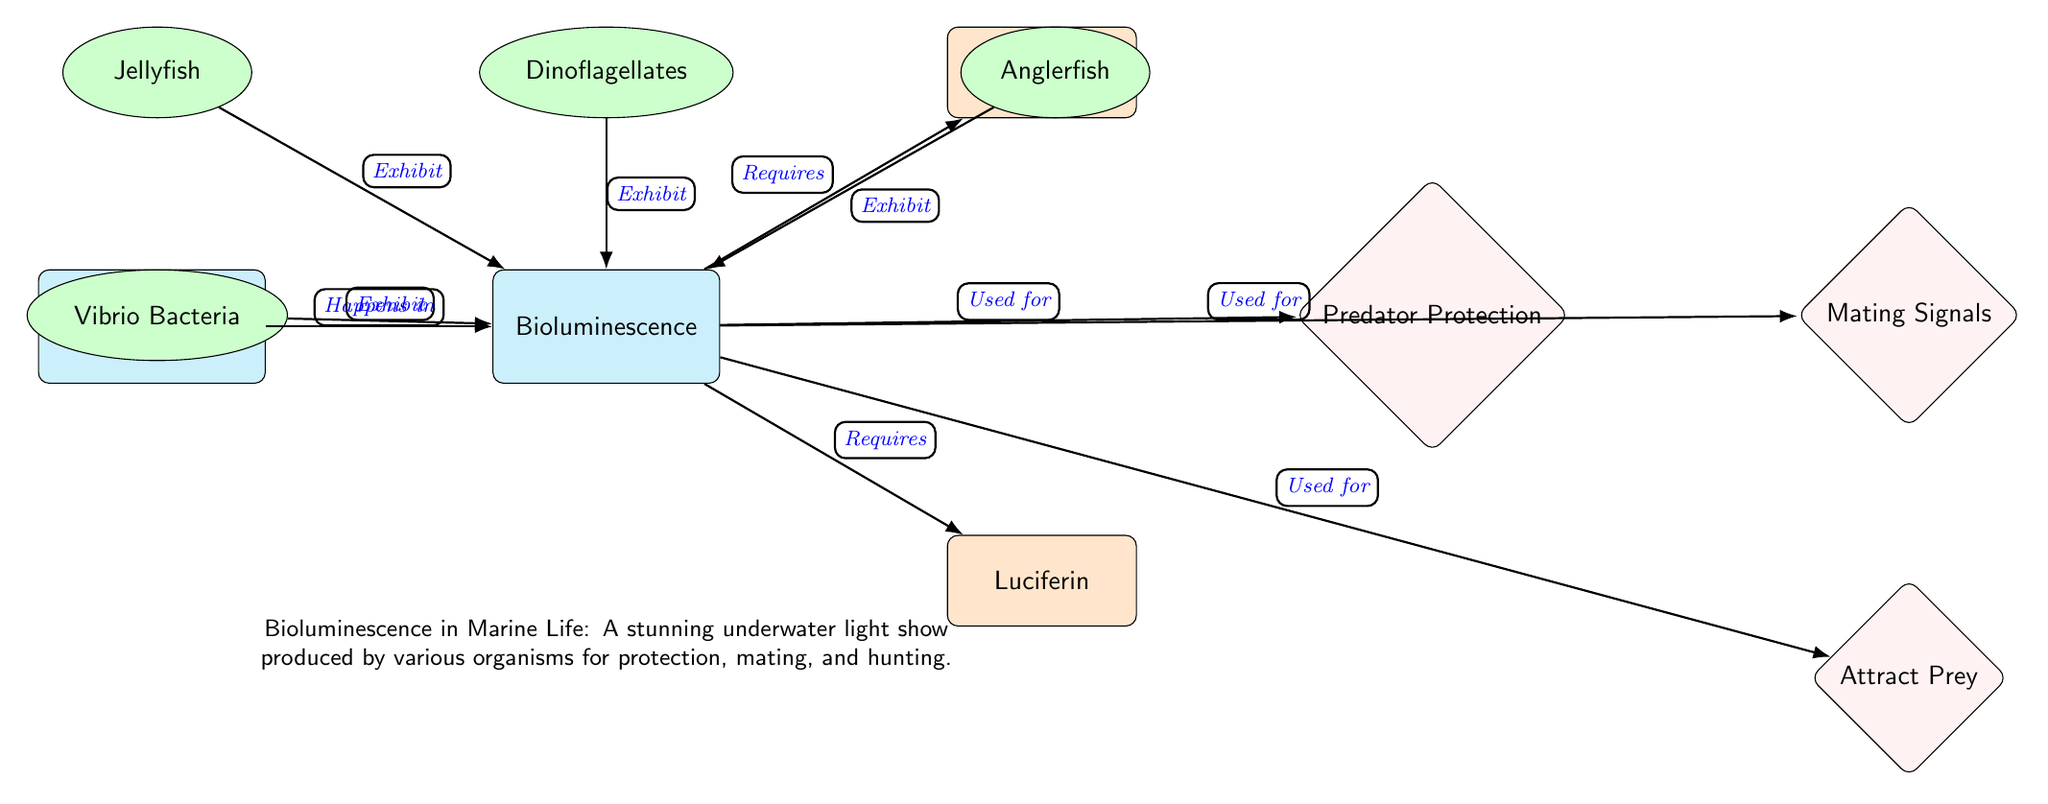What are the two main components required for bioluminescence? The diagram shows two processes that are required for bioluminescence: luciferase and luciferin. These are indicated by the edges pointing into the "Bioluminescence" node.
Answer: Luciferase, luciferin What organism exhibits bioluminescence alongside dinoflagellates? The diagram lists several organisms that exhibit bioluminescence, including jellyfish, which is directly connected to the bioluminescence node.
Answer: Jellyfish How many purposes are listed for bioluminescence? The diagram includes three purposes for bioluminescence as indicated by the three edges leading to the purpose nodes (predator protection, mating signals, attract prey).
Answer: Three What purpose does bioluminescence serve that helps in reproduction? The diagram highlights the mating signals purpose, which is connected to the bioluminescence node.
Answer: Mating signals Which bacterium is listed as exhibiting bioluminescence? The diagram identifies Vibrio Bacteria as one of the organisms that exhibit bioluminescence, as shown by its link to the bioluminescence node.
Answer: Vibrio Bacteria What is the main event described in the diagram regarding marine life? The diagram emphasizes bioluminescence as the main event, specifically stating "Bioluminescence in Marine Life," located at the centre of the diagram.
Answer: Bioluminescence Which organism is positioned to the right of dinoflagellates in the diagram? According to the diagram's layout, the anglerfish is directly positioned to the right of dinoflagellates.
Answer: Anglerfish What relationship connects bioluminescence to predator protection? The diagram illustrates that bioluminescence is used for the purpose of predator protection, as indicated by the directed edge from the bioluminescence node to the purpose node for predator protection.
Answer: Used for predator protection How does bioluminescence benefit anglerfish? The diagram implies that anglerfish exhibit bioluminescence for the purpose of attracting prey, indicated by the connecting edge to the respective purpose node.
Answer: Attract prey 